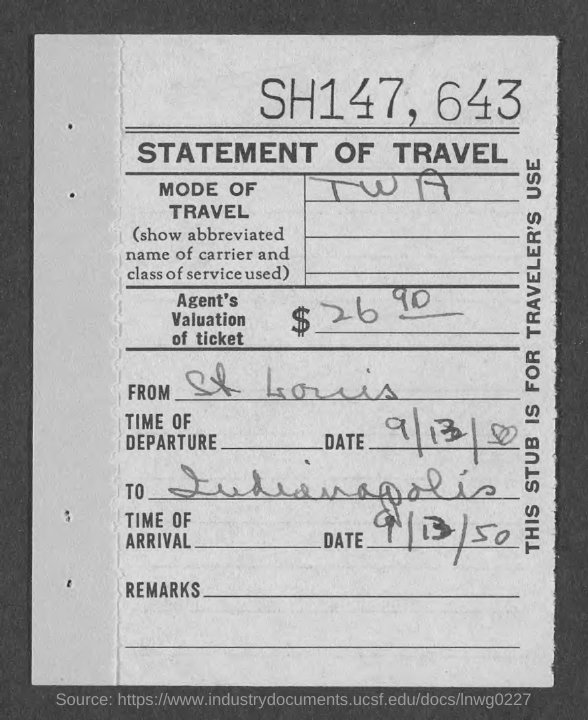What is the Title of the document?
Your answer should be compact. STATEMENT OF TRAVEL. What is the mode of travel?
Your response must be concise. TWA. Where is it from?
Provide a short and direct response. St Louis. What is the date of departure?
Offer a very short reply. 9/13/50. What is the date of arrival?
Ensure brevity in your answer.  9/13/50. 